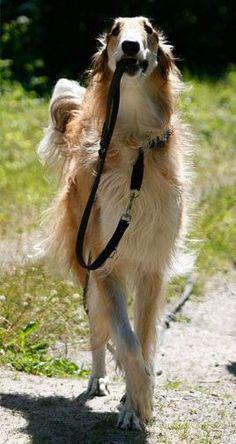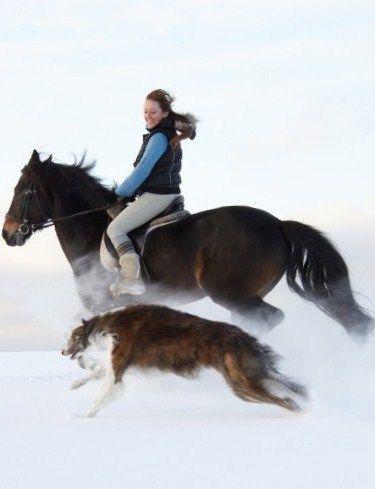The first image is the image on the left, the second image is the image on the right. Analyze the images presented: Is the assertion "One image shows at least one hound in a raft on water, and the other image shows a hound that is upright and trotting." valid? Answer yes or no. No. The first image is the image on the left, the second image is the image on the right. For the images shown, is this caption "An image contains at least one dog inside an inflatable flotation device." true? Answer yes or no. No. 